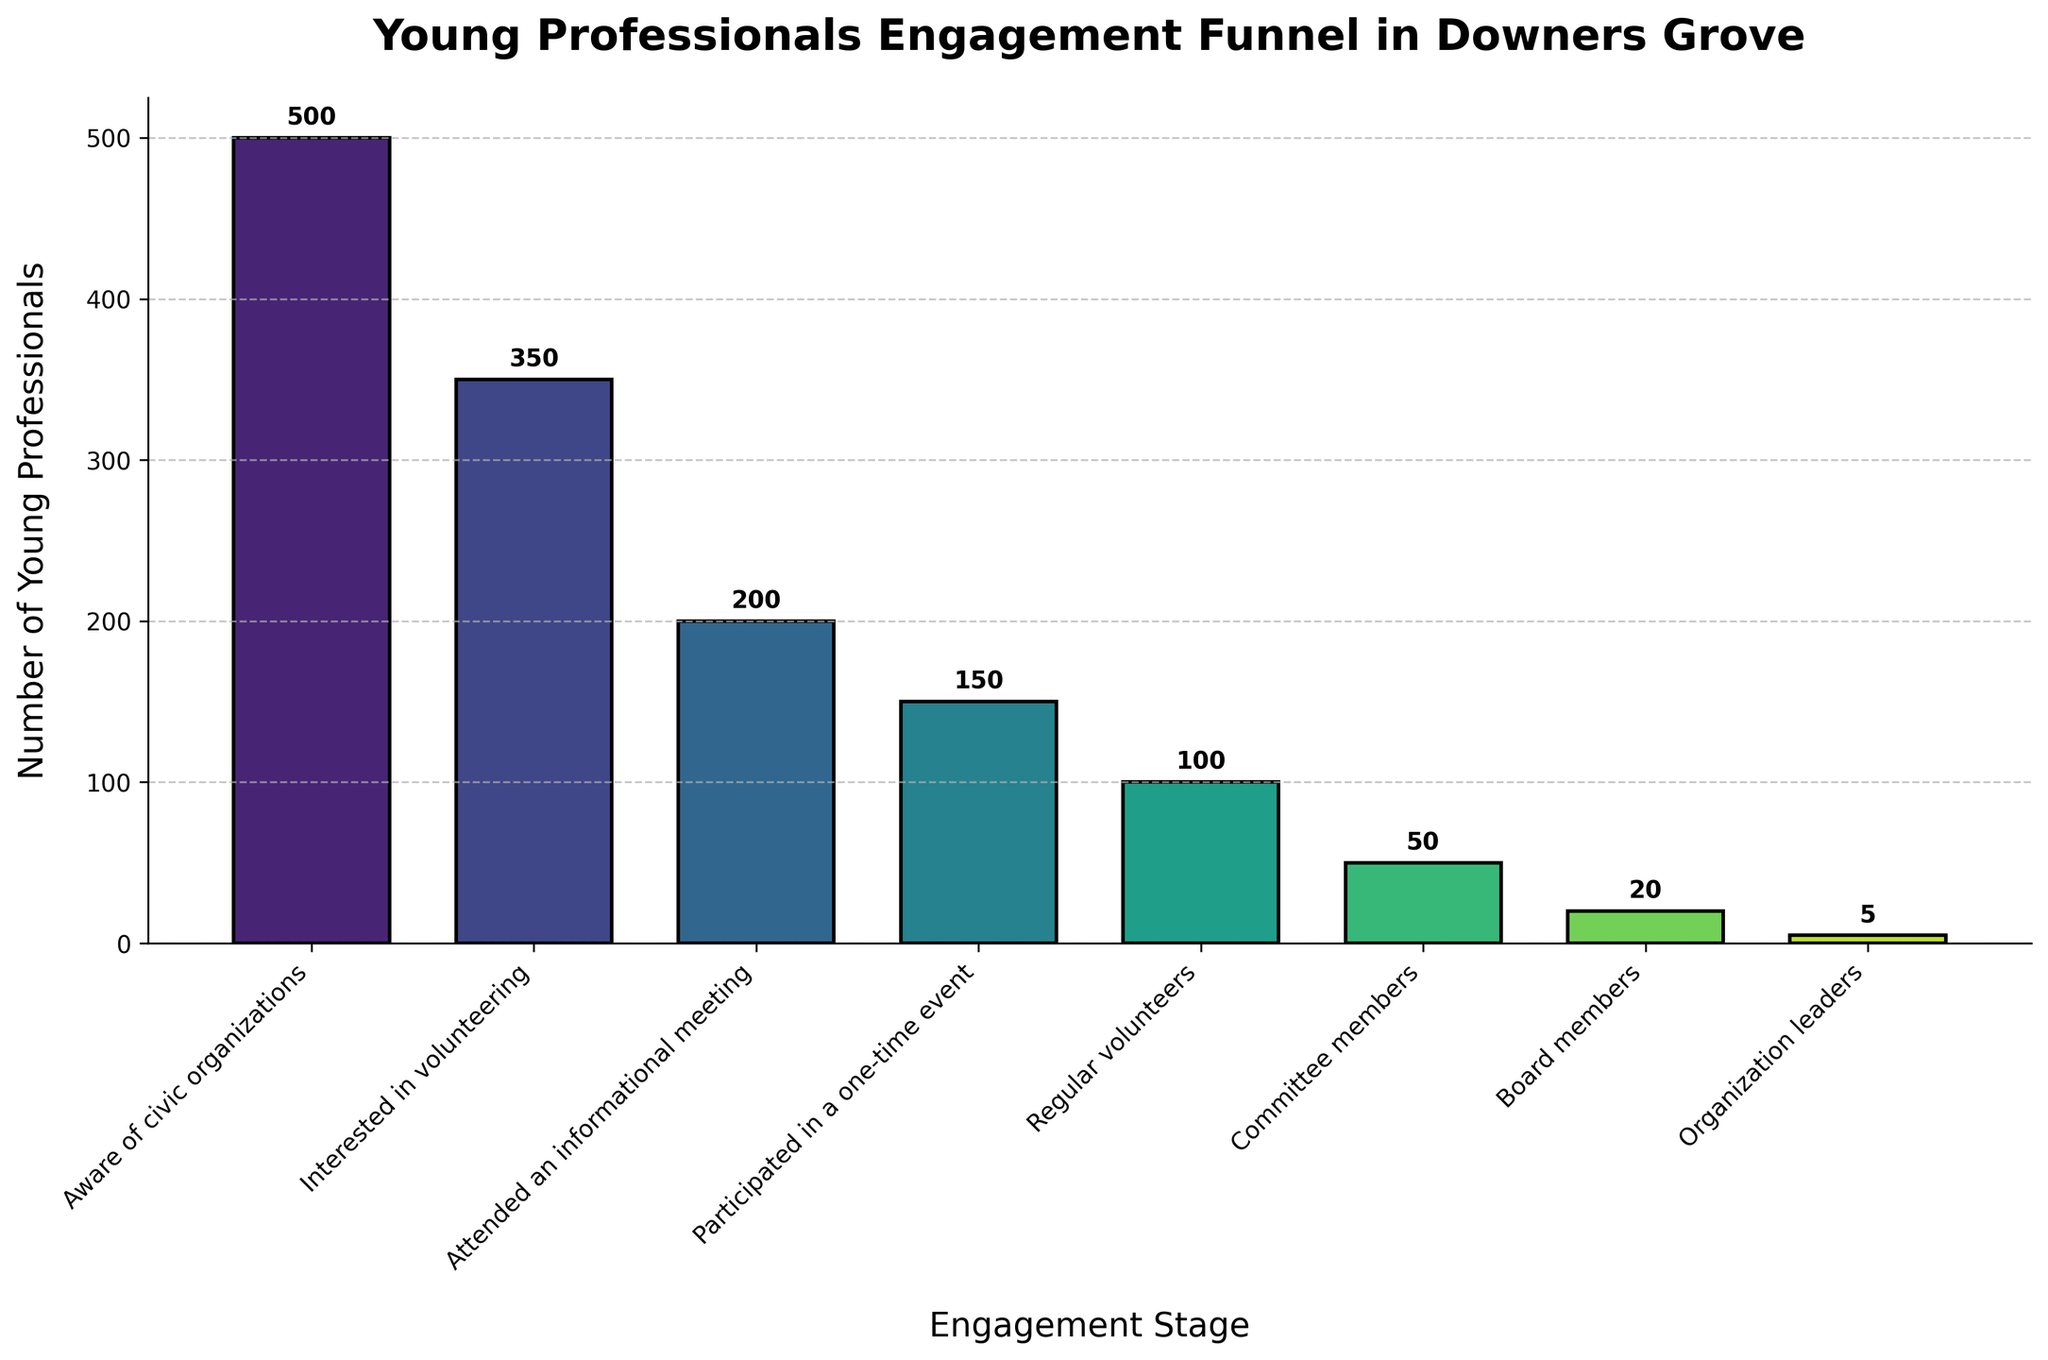What's the title of the figure? The title of the figure is typically prominently displayed at the top and summarizes the main topic.
Answer: Young Professionals Engagement Funnel in Downers Grove How many stages are there in the funnel? By counting the distinct engagement stages on the x-axis, we can determine the number of stages.
Answer: 8 Which stage has the highest number of young professionals? By identifying the bar with the greatest height on the chart, we can determine which stage has the most young professionals. In this case, the first bar is the tallest.
Answer: Aware of civic organizations How many young professionals are regular volunteers? Find the stage labeled "Regular volunteers" and read the number directly from the top of the corresponding bar.
Answer: 100 What's the total number of young professionals involved at every stage? Sum the values of all the stages to get the total number. 500 + 350 + 200 + 150 + 100 + 50 + 20 + 5.
Answer: 1375 What is the difference in the number of professionals between the 'Interested in volunteering' and 'Attended an informational meeting' stages? Subtract the number of professionals at the 'Attended an informational meeting' stage from the 'Interested in volunteering' stage: 350 - 200.
Answer: 150 How does the number of 'Board members' compare to 'Organization leaders'? Compare the heights of the bars for 'Board members' and 'Organization leaders'. The number for 'Board members' is higher.
Answer: Higher What percentage of those 'Aware of civic organizations' are 'Organization leaders'? Divide the number of 'Organization leaders' by those 'Aware of civic organizations' and multiply by 100 for the percentage: (5 / 500) * 100 = 1%.
Answer: 1% What's the average number of young professionals per stage? Sum the total number of young professionals and divide by the number of stages: 1375 / 8.
Answer: 171.875 Which stage experiences the largest drop in the number of participants compared to the previous stage? Calculate the differences between consecutive stages and compare to find the largest drop. The largest drop is from 'Interested in volunteering' (350) to 'Attended an informational meeting' (200), which is 150.
Answer: From Interested in volunteering to Attended an informational meeting 